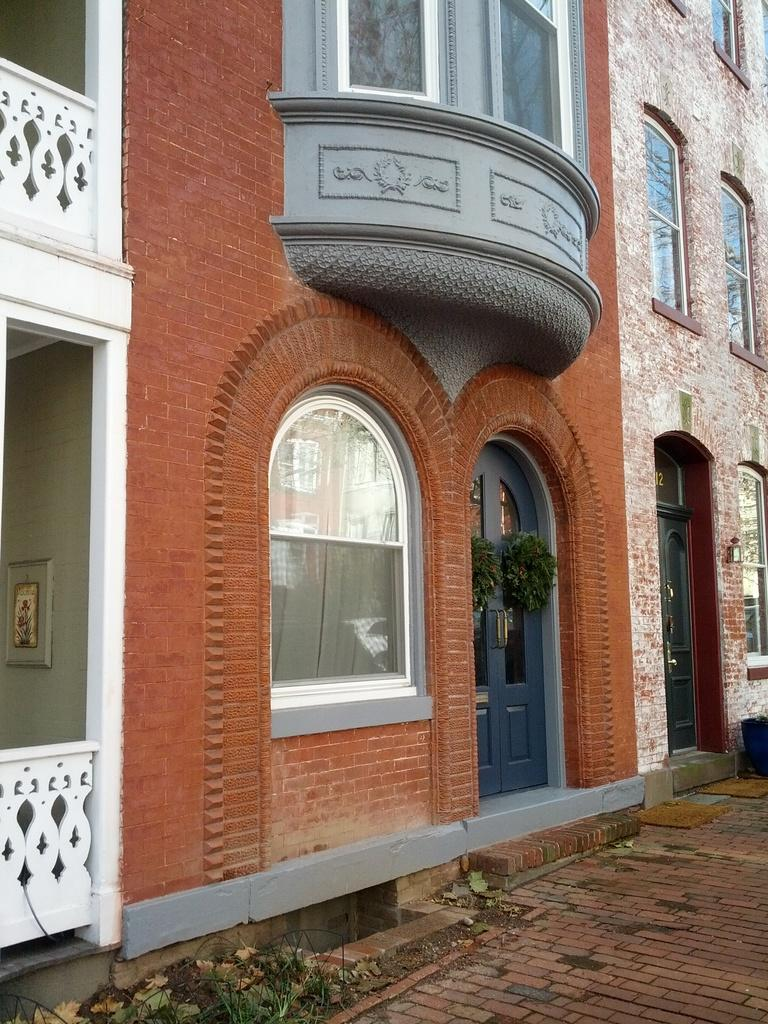What is located in the center of the image? There are buildings in the center of the image. What is visible at the bottom of the image? There is a floor visible at the bottom of the image. Where is the desk located in the image? There is no desk present in the image. What type of vegetable can be seen growing on the floor in the image? There are no vegetables visible in the image; only buildings and a floor are present. 